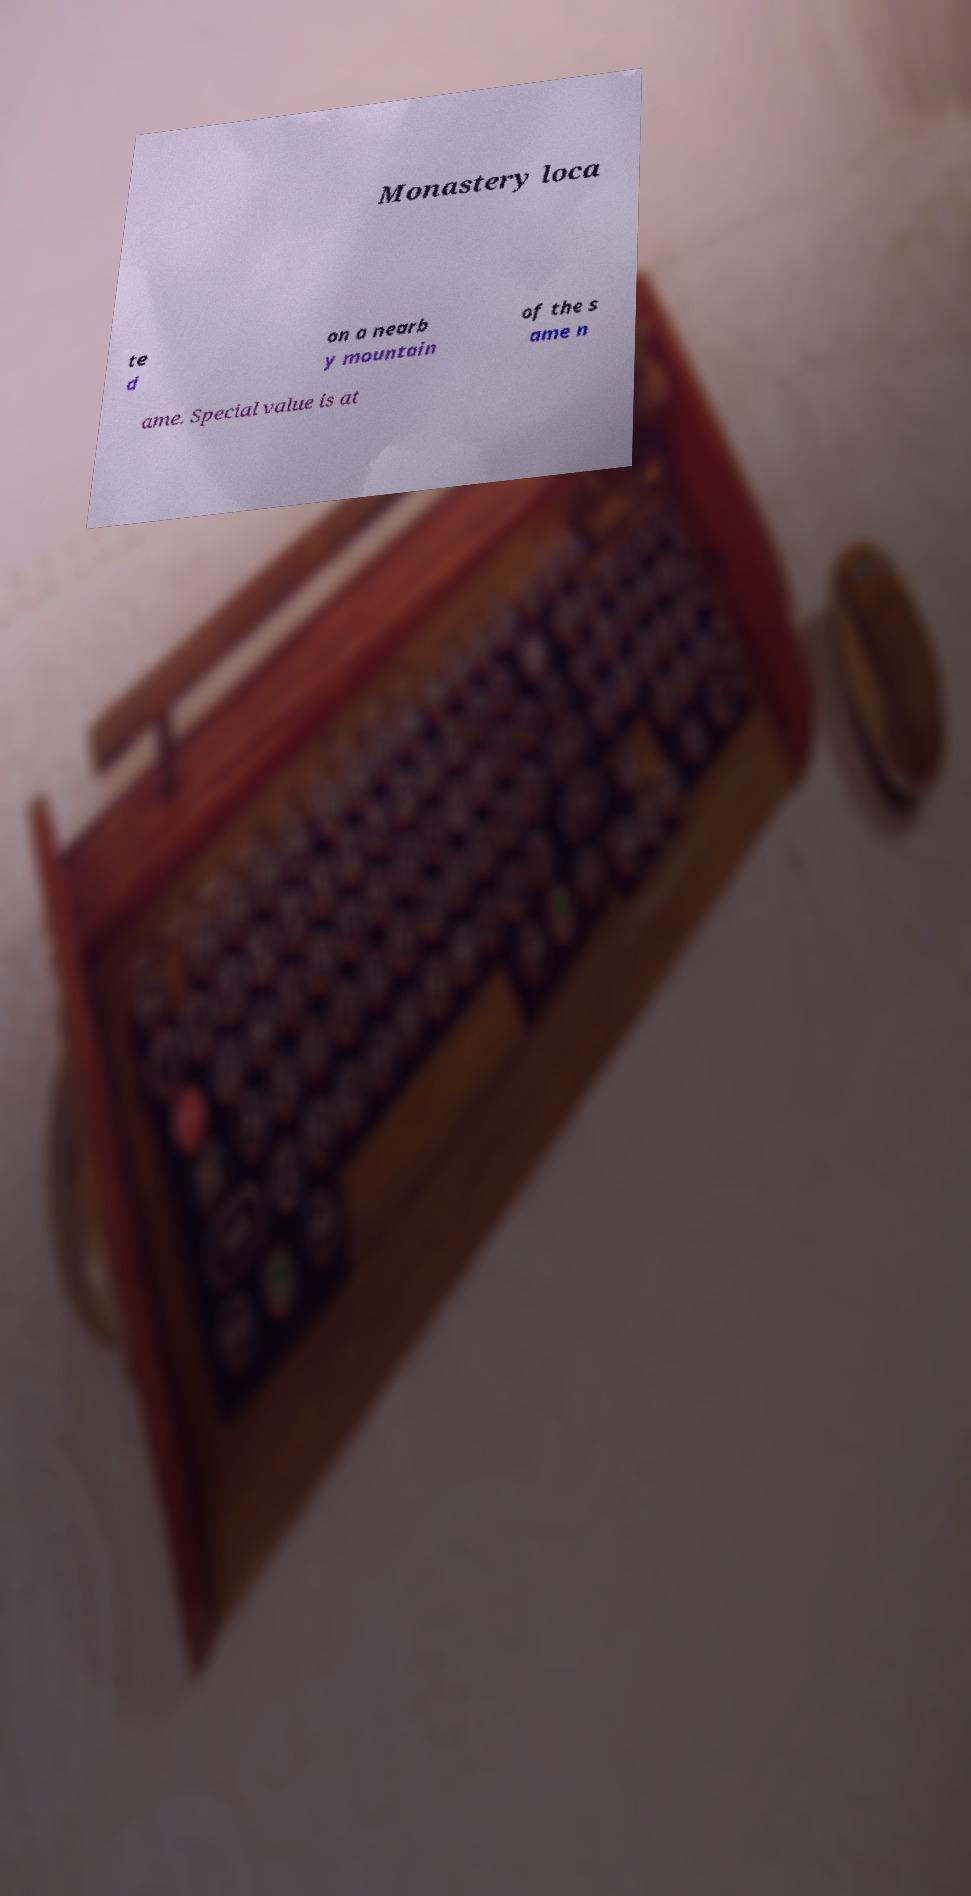I need the written content from this picture converted into text. Can you do that? Monastery loca te d on a nearb y mountain of the s ame n ame. Special value is at 